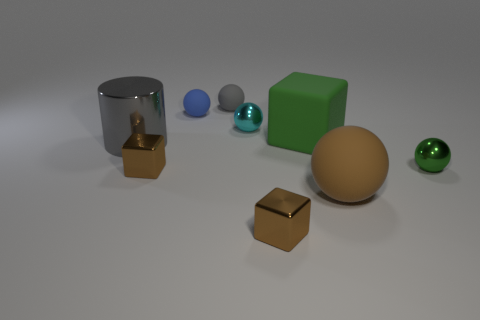Subtract all big brown rubber spheres. How many spheres are left? 4 Subtract all blue balls. How many brown cubes are left? 2 Subtract all cyan balls. How many balls are left? 4 Subtract 2 cubes. How many cubes are left? 1 Subtract all spheres. How many objects are left? 4 Subtract 1 brown spheres. How many objects are left? 8 Subtract all purple blocks. Subtract all gray spheres. How many blocks are left? 3 Subtract all matte blocks. Subtract all brown matte things. How many objects are left? 7 Add 5 tiny shiny cubes. How many tiny shiny cubes are left? 7 Add 8 large cubes. How many large cubes exist? 9 